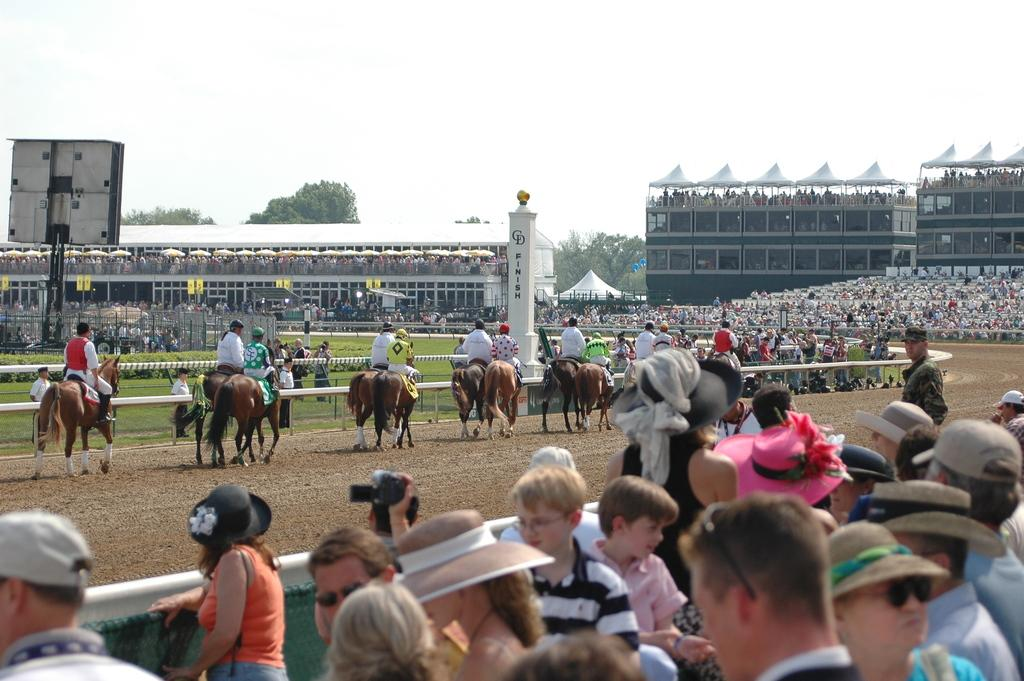What is the main subject of the image? The main subject of the image is a group of jockeys. What are the jockeys doing in the image? The jockeys are riding horses in the image. Are there any other people present in the image besides the jockeys? Yes, there are people on either side of the jockeys in the image. What type of fiction is the jockey reading while riding the horse in the image? There is no indication in the image that the jockey is reading any fiction while riding the horse. 